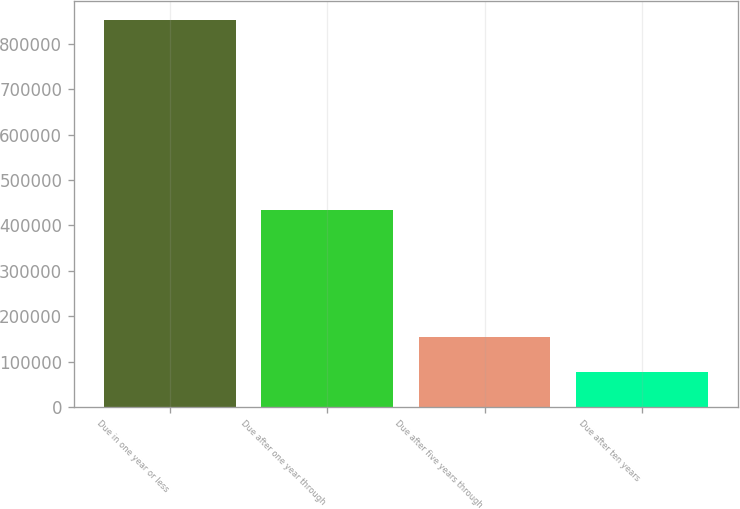Convert chart. <chart><loc_0><loc_0><loc_500><loc_500><bar_chart><fcel>Due in one year or less<fcel>Due after one year through<fcel>Due after five years through<fcel>Due after ten years<nl><fcel>851133<fcel>433135<fcel>155168<fcel>77839<nl></chart> 